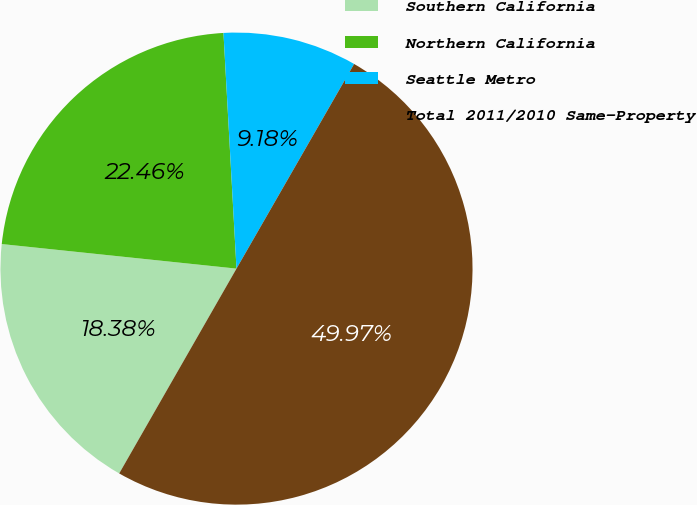Convert chart. <chart><loc_0><loc_0><loc_500><loc_500><pie_chart><fcel>Southern California<fcel>Northern California<fcel>Seattle Metro<fcel>Total 2011/2010 Same-Property<nl><fcel>18.38%<fcel>22.46%<fcel>9.18%<fcel>49.97%<nl></chart> 